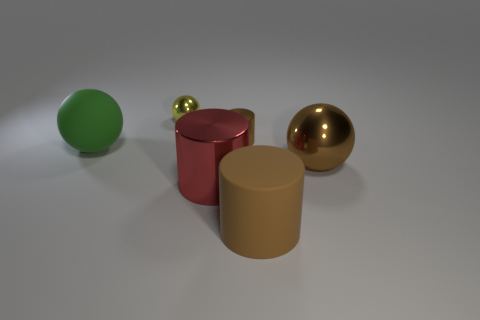The small metal cylinder is what color?
Your answer should be very brief. Brown. What is the color of the shiny sphere that is behind the brown cylinder that is behind the large red object?
Provide a short and direct response. Yellow. What is the shape of the large object that is on the left side of the big shiny thing that is in front of the metal object to the right of the brown rubber cylinder?
Make the answer very short. Sphere. How many small yellow spheres have the same material as the big red object?
Make the answer very short. 1. There is a rubber thing that is to the right of the tiny metallic sphere; what number of large cylinders are on the left side of it?
Ensure brevity in your answer.  1. What number of large green matte objects are there?
Offer a very short reply. 1. Is the material of the yellow sphere the same as the brown cylinder in front of the big red metallic object?
Offer a terse response. No. There is a large matte object that is in front of the large metallic cylinder; is its color the same as the matte sphere?
Offer a terse response. No. There is a ball that is both in front of the small shiny ball and on the right side of the big green thing; what material is it made of?
Give a very brief answer. Metal. What size is the yellow thing?
Give a very brief answer. Small. 